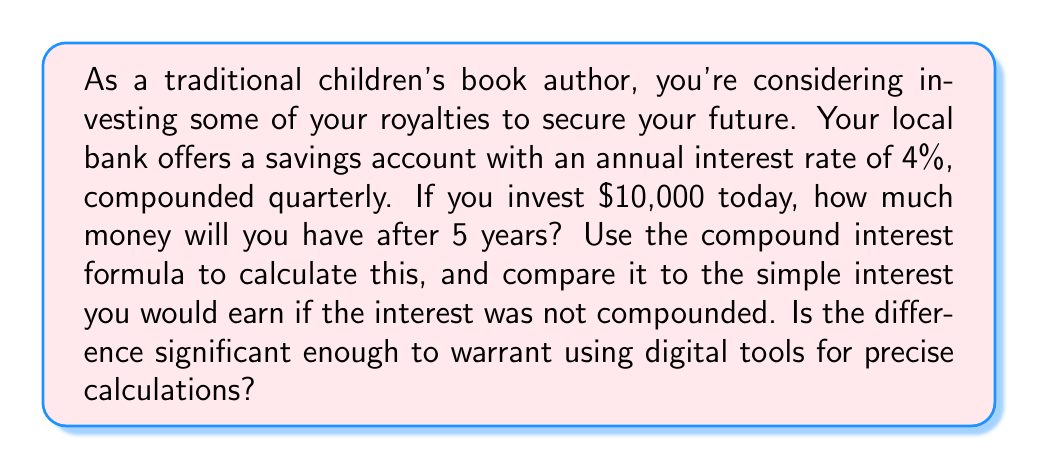Help me with this question. To solve this problem, we'll use the compound interest formula:

$$A = P(1 + \frac{r}{n})^{nt}$$

Where:
$A$ = final amount
$P$ = principal (initial investment)
$r$ = annual interest rate (as a decimal)
$n$ = number of times interest is compounded per year
$t$ = number of years

Given:
$P = 10000$
$r = 0.04$ (4% expressed as a decimal)
$n = 4$ (compounded quarterly, so 4 times per year)
$t = 5$ years

Let's plug these values into the formula:

$$A = 10000(1 + \frac{0.04}{4})^{4 \cdot 5}$$
$$A = 10000(1 + 0.01)^{20}$$
$$A = 10000(1.01)^{20}$$

Using a calculator (as precise manual calculation would be tedious):

$$A \approx 12201.90$$

For comparison, let's calculate simple interest:
Simple Interest = $P \cdot r \cdot t = 10000 \cdot 0.04 \cdot 5 = 2000$
Total with simple interest = $10000 + 2000 = 12000$

The difference between compound and simple interest is:
$12201.90 - 12000 = 201.90$

This difference, while not enormous, is significant enough to consider using digital tools for precise calculations, especially for larger amounts or longer time periods.
Answer: $12201.90 